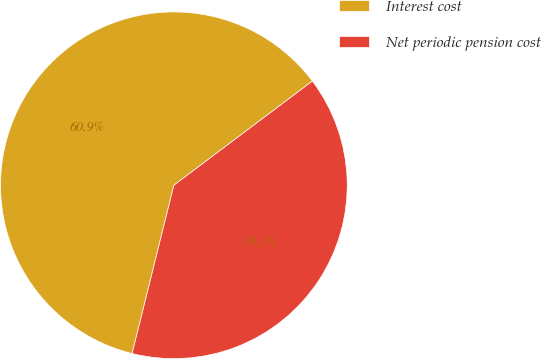Convert chart. <chart><loc_0><loc_0><loc_500><loc_500><pie_chart><fcel>Interest cost<fcel>Net periodic pension cost<nl><fcel>60.87%<fcel>39.13%<nl></chart> 